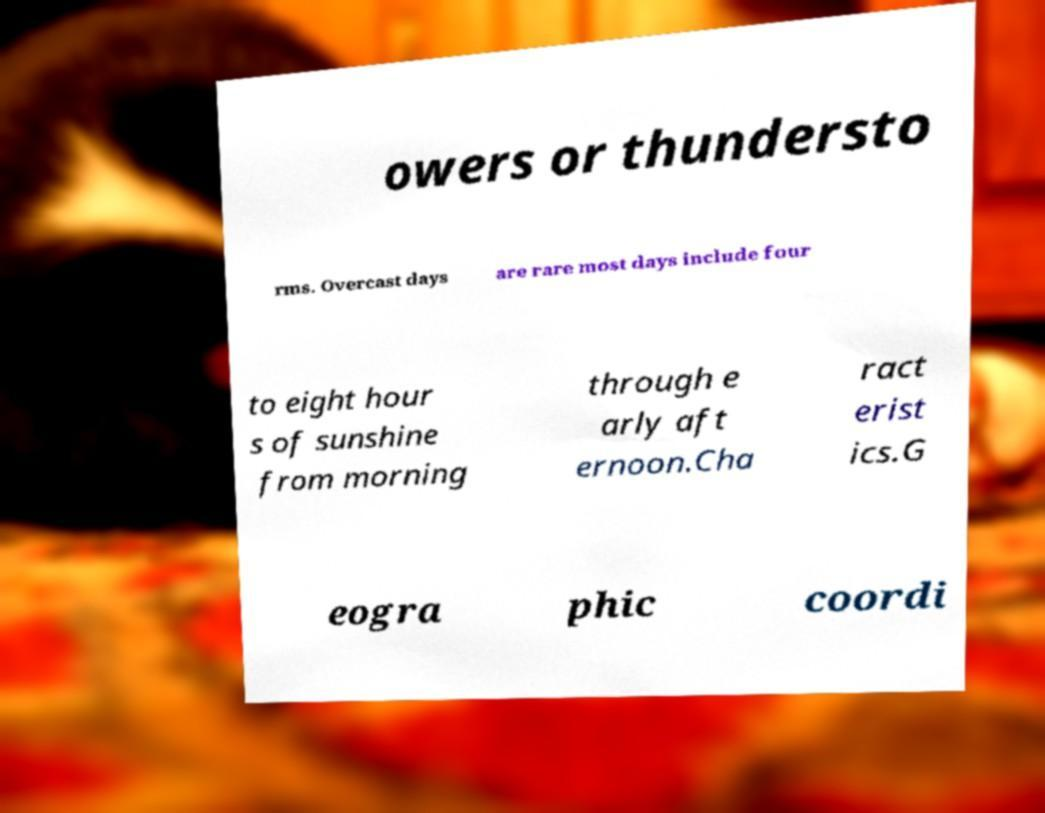There's text embedded in this image that I need extracted. Can you transcribe it verbatim? owers or thundersto rms. Overcast days are rare most days include four to eight hour s of sunshine from morning through e arly aft ernoon.Cha ract erist ics.G eogra phic coordi 